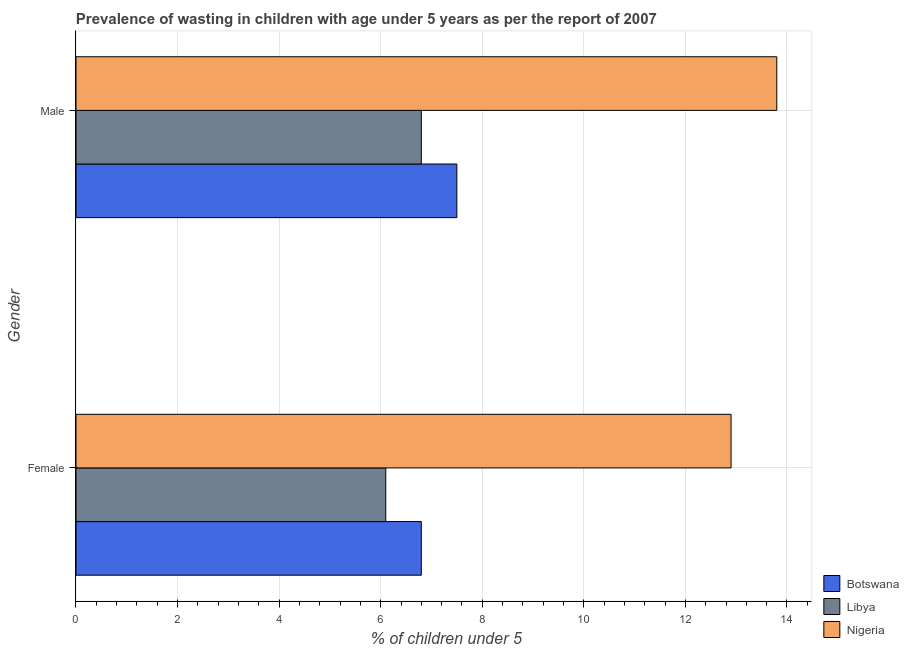Are the number of bars on each tick of the Y-axis equal?
Your answer should be compact. Yes. How many bars are there on the 1st tick from the top?
Your answer should be very brief. 3. What is the percentage of undernourished male children in Libya?
Provide a succinct answer. 6.8. Across all countries, what is the maximum percentage of undernourished female children?
Make the answer very short. 12.9. Across all countries, what is the minimum percentage of undernourished female children?
Make the answer very short. 6.1. In which country was the percentage of undernourished female children maximum?
Give a very brief answer. Nigeria. In which country was the percentage of undernourished male children minimum?
Provide a succinct answer. Libya. What is the total percentage of undernourished female children in the graph?
Your response must be concise. 25.8. What is the difference between the percentage of undernourished female children in Libya and that in Nigeria?
Your answer should be very brief. -6.8. What is the difference between the percentage of undernourished female children in Libya and the percentage of undernourished male children in Botswana?
Your answer should be very brief. -1.4. What is the average percentage of undernourished female children per country?
Ensure brevity in your answer.  8.6. What is the difference between the percentage of undernourished female children and percentage of undernourished male children in Botswana?
Ensure brevity in your answer.  -0.7. In how many countries, is the percentage of undernourished male children greater than 6.8 %?
Your answer should be very brief. 3. What is the ratio of the percentage of undernourished female children in Nigeria to that in Libya?
Your response must be concise. 2.11. Is the percentage of undernourished female children in Botswana less than that in Nigeria?
Keep it short and to the point. Yes. In how many countries, is the percentage of undernourished male children greater than the average percentage of undernourished male children taken over all countries?
Your answer should be compact. 1. What does the 2nd bar from the top in Male represents?
Provide a succinct answer. Libya. What does the 2nd bar from the bottom in Female represents?
Your response must be concise. Libya. Are all the bars in the graph horizontal?
Give a very brief answer. Yes. What is the difference between two consecutive major ticks on the X-axis?
Provide a short and direct response. 2. Are the values on the major ticks of X-axis written in scientific E-notation?
Offer a very short reply. No. Does the graph contain grids?
Make the answer very short. Yes. How many legend labels are there?
Give a very brief answer. 3. What is the title of the graph?
Your response must be concise. Prevalence of wasting in children with age under 5 years as per the report of 2007. What is the label or title of the X-axis?
Ensure brevity in your answer.   % of children under 5. What is the label or title of the Y-axis?
Provide a succinct answer. Gender. What is the  % of children under 5 of Botswana in Female?
Offer a terse response. 6.8. What is the  % of children under 5 in Libya in Female?
Make the answer very short. 6.1. What is the  % of children under 5 in Nigeria in Female?
Your response must be concise. 12.9. What is the  % of children under 5 of Libya in Male?
Your response must be concise. 6.8. What is the  % of children under 5 of Nigeria in Male?
Offer a terse response. 13.8. Across all Gender, what is the maximum  % of children under 5 of Libya?
Your answer should be compact. 6.8. Across all Gender, what is the maximum  % of children under 5 of Nigeria?
Ensure brevity in your answer.  13.8. Across all Gender, what is the minimum  % of children under 5 in Botswana?
Offer a terse response. 6.8. Across all Gender, what is the minimum  % of children under 5 in Libya?
Ensure brevity in your answer.  6.1. Across all Gender, what is the minimum  % of children under 5 in Nigeria?
Offer a very short reply. 12.9. What is the total  % of children under 5 of Nigeria in the graph?
Offer a very short reply. 26.7. What is the difference between the  % of children under 5 in Botswana in Female and that in Male?
Your answer should be very brief. -0.7. What is the difference between the  % of children under 5 in Nigeria in Female and that in Male?
Offer a very short reply. -0.9. What is the difference between the  % of children under 5 of Libya in Female and the  % of children under 5 of Nigeria in Male?
Offer a terse response. -7.7. What is the average  % of children under 5 in Botswana per Gender?
Make the answer very short. 7.15. What is the average  % of children under 5 in Libya per Gender?
Your answer should be compact. 6.45. What is the average  % of children under 5 in Nigeria per Gender?
Make the answer very short. 13.35. What is the difference between the  % of children under 5 in Libya and  % of children under 5 in Nigeria in Female?
Offer a terse response. -6.8. What is the difference between the  % of children under 5 in Botswana and  % of children under 5 in Nigeria in Male?
Ensure brevity in your answer.  -6.3. What is the ratio of the  % of children under 5 of Botswana in Female to that in Male?
Make the answer very short. 0.91. What is the ratio of the  % of children under 5 in Libya in Female to that in Male?
Keep it short and to the point. 0.9. What is the ratio of the  % of children under 5 in Nigeria in Female to that in Male?
Your answer should be compact. 0.93. What is the difference between the highest and the second highest  % of children under 5 of Botswana?
Keep it short and to the point. 0.7. What is the difference between the highest and the lowest  % of children under 5 of Botswana?
Provide a succinct answer. 0.7. What is the difference between the highest and the lowest  % of children under 5 in Libya?
Your answer should be compact. 0.7. 